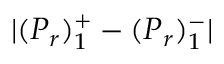Convert formula to latex. <formula><loc_0><loc_0><loc_500><loc_500>| ( P _ { r } ) _ { 1 } ^ { + } - ( P _ { r } ) _ { 1 } ^ { - } |</formula> 